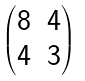Convert formula to latex. <formula><loc_0><loc_0><loc_500><loc_500>\begin{pmatrix} 8 & 4 \\ 4 & 3 \end{pmatrix}</formula> 